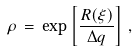Convert formula to latex. <formula><loc_0><loc_0><loc_500><loc_500>\rho \, = \, \exp \left [ \frac { R ( \xi ) } { \Delta q } \right ] \, ,</formula> 